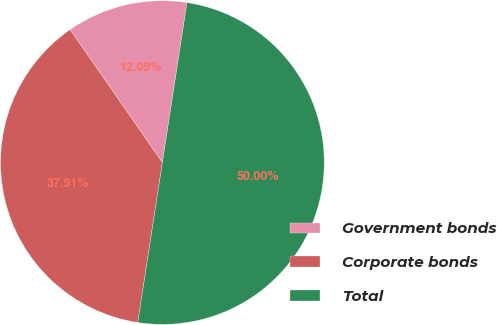<chart> <loc_0><loc_0><loc_500><loc_500><pie_chart><fcel>Government bonds<fcel>Corporate bonds<fcel>Total<nl><fcel>12.09%<fcel>37.91%<fcel>50.0%<nl></chart> 